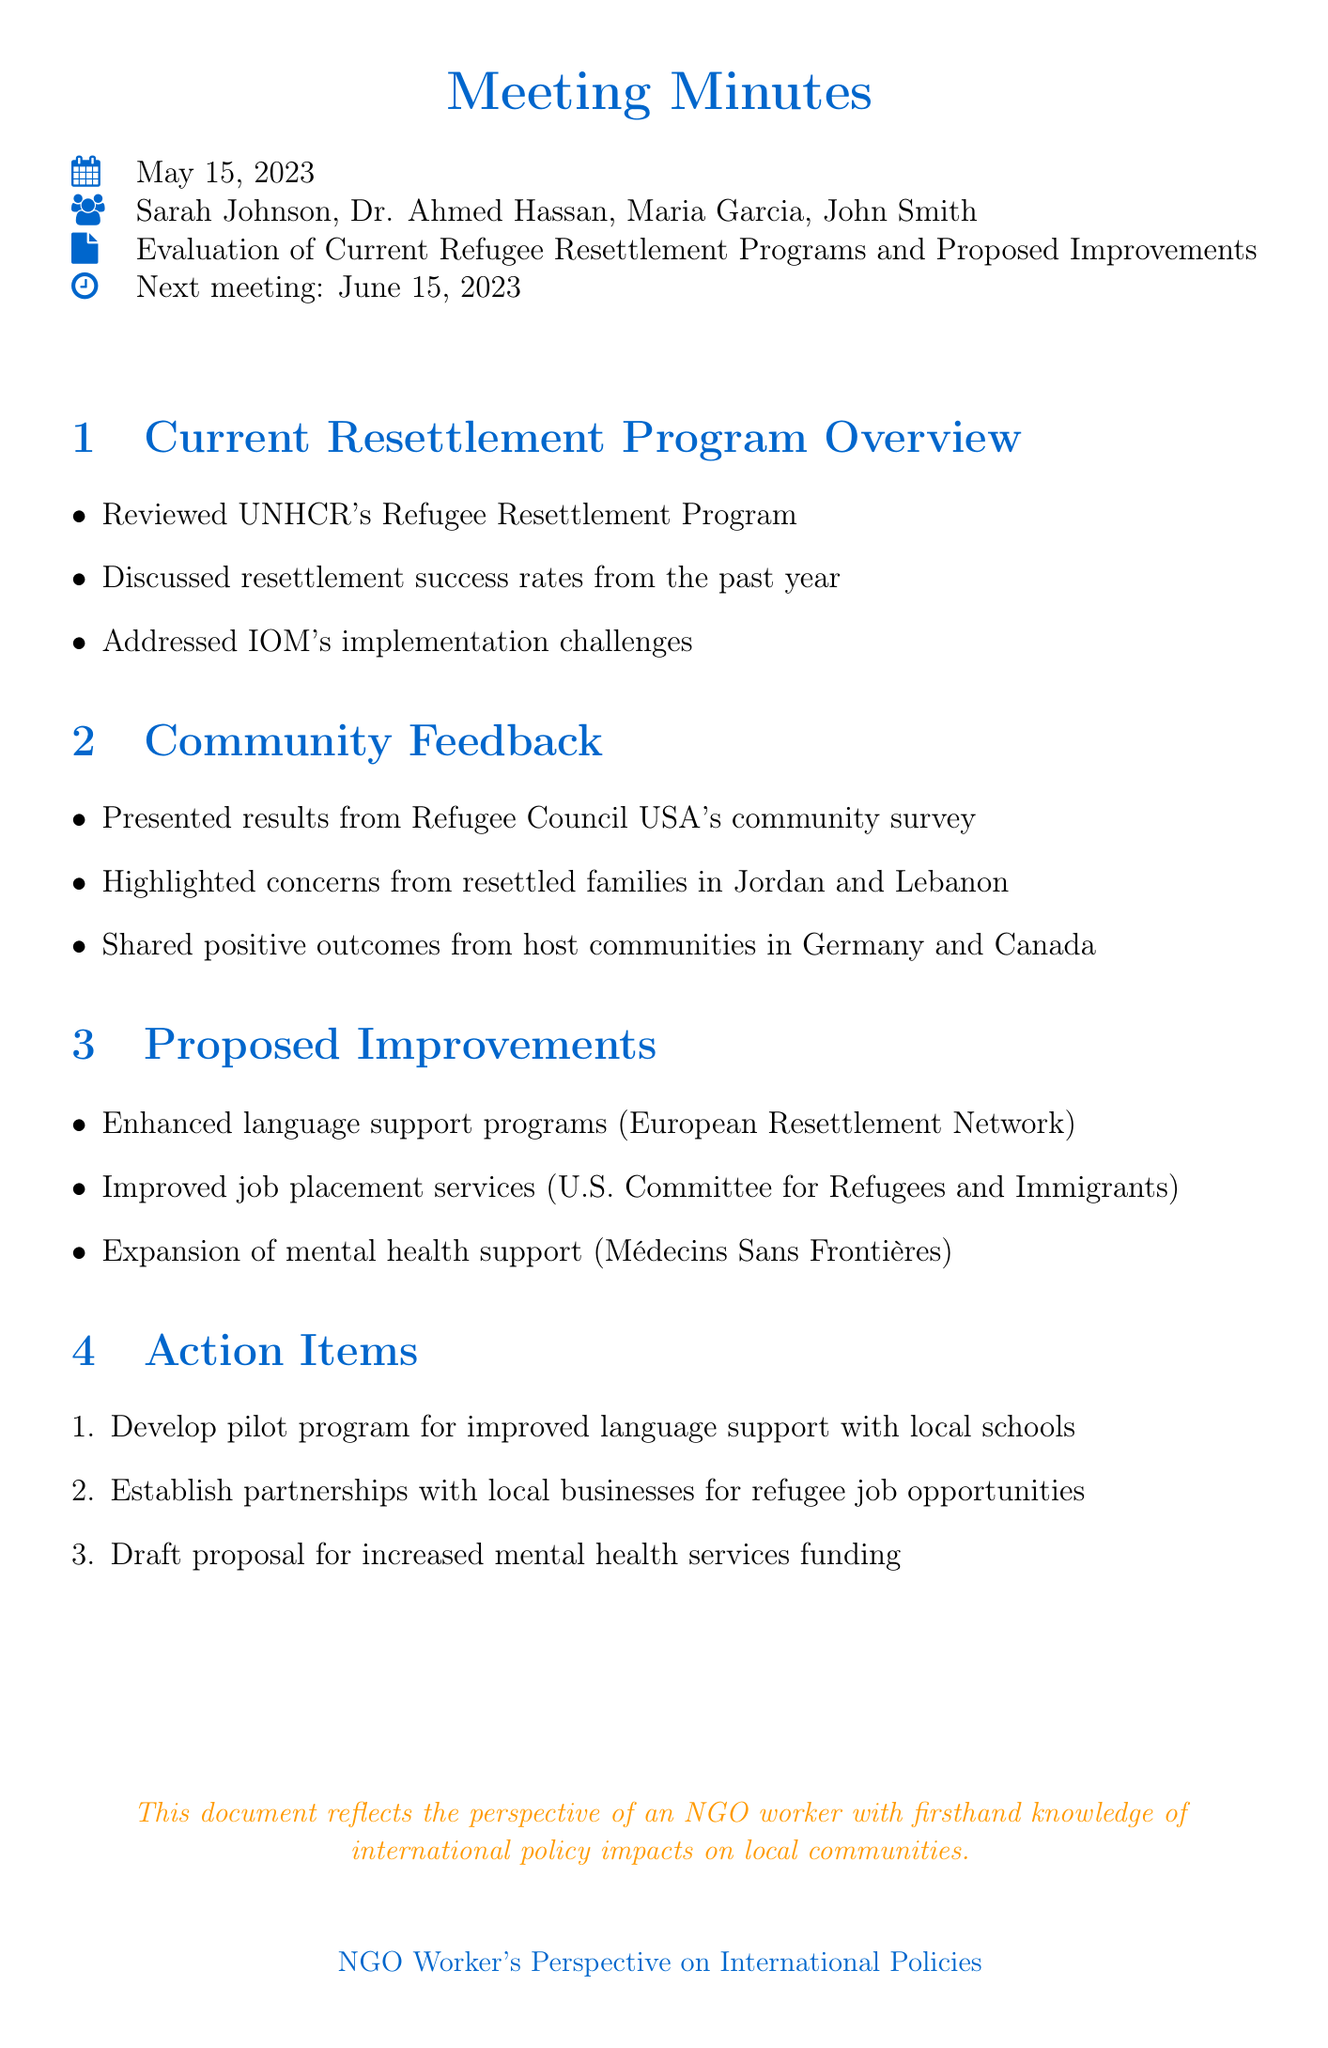What is the date of the meeting? The date of the meeting is specified at the beginning of the document as May 15, 2023.
Answer: May 15, 2023 Who is the NGO representative? The document lists Sarah Johnson as the NGO representative among the attendees.
Answer: Sarah Johnson What are the key concerns raised by resettled families? The document outlines those concerns under the Community Feedback section, stating it included issues from families in Jordan and Lebanon.
Answer: Concerns from resettled families in Jordan and Lebanon What is one proposed improvement related to mental health? The document specifies that the expansion of mental health support is a proposed improvement, recommended by Médecins Sans Frontières.
Answer: Expansion of mental health support How many action items were discussed in the meeting? The document lists three action items under the Action Items section, indicating the number of proposals discussed.
Answer: Three What program is to be developed in collaboration with local schools? The document states that a pilot program for improved language support is to be developed with local schools.
Answer: Improved language support program What was the next meeting date? The document clearly states the date of the next meeting following the action items discussed.
Answer: June 15, 2023 What organization conducted the community survey? The document mentions the Refugee Council USA as the organization that conducted the community survey.
Answer: Refugee Council USA 